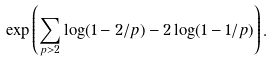Convert formula to latex. <formula><loc_0><loc_0><loc_500><loc_500>\exp \left ( \sum _ { p > 2 } \log ( 1 - 2 / p ) - 2 \log ( 1 - 1 / p ) \right ) .</formula> 